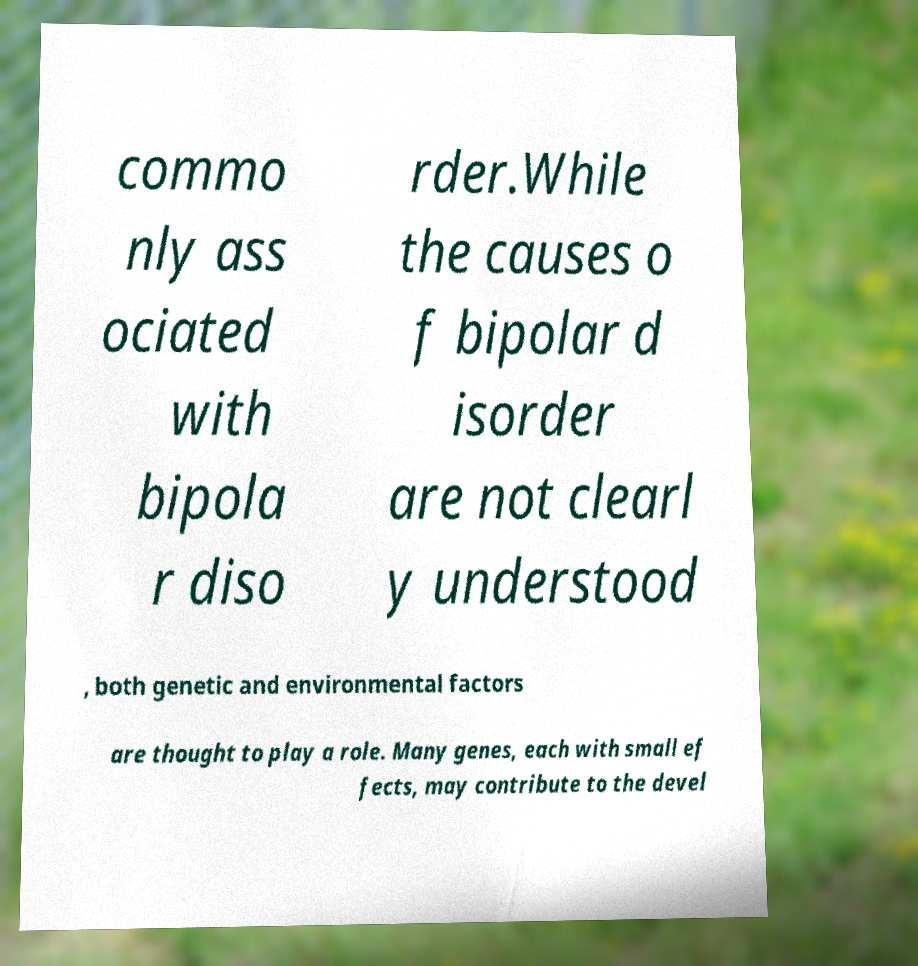Can you read and provide the text displayed in the image?This photo seems to have some interesting text. Can you extract and type it out for me? commo nly ass ociated with bipola r diso rder.While the causes o f bipolar d isorder are not clearl y understood , both genetic and environmental factors are thought to play a role. Many genes, each with small ef fects, may contribute to the devel 